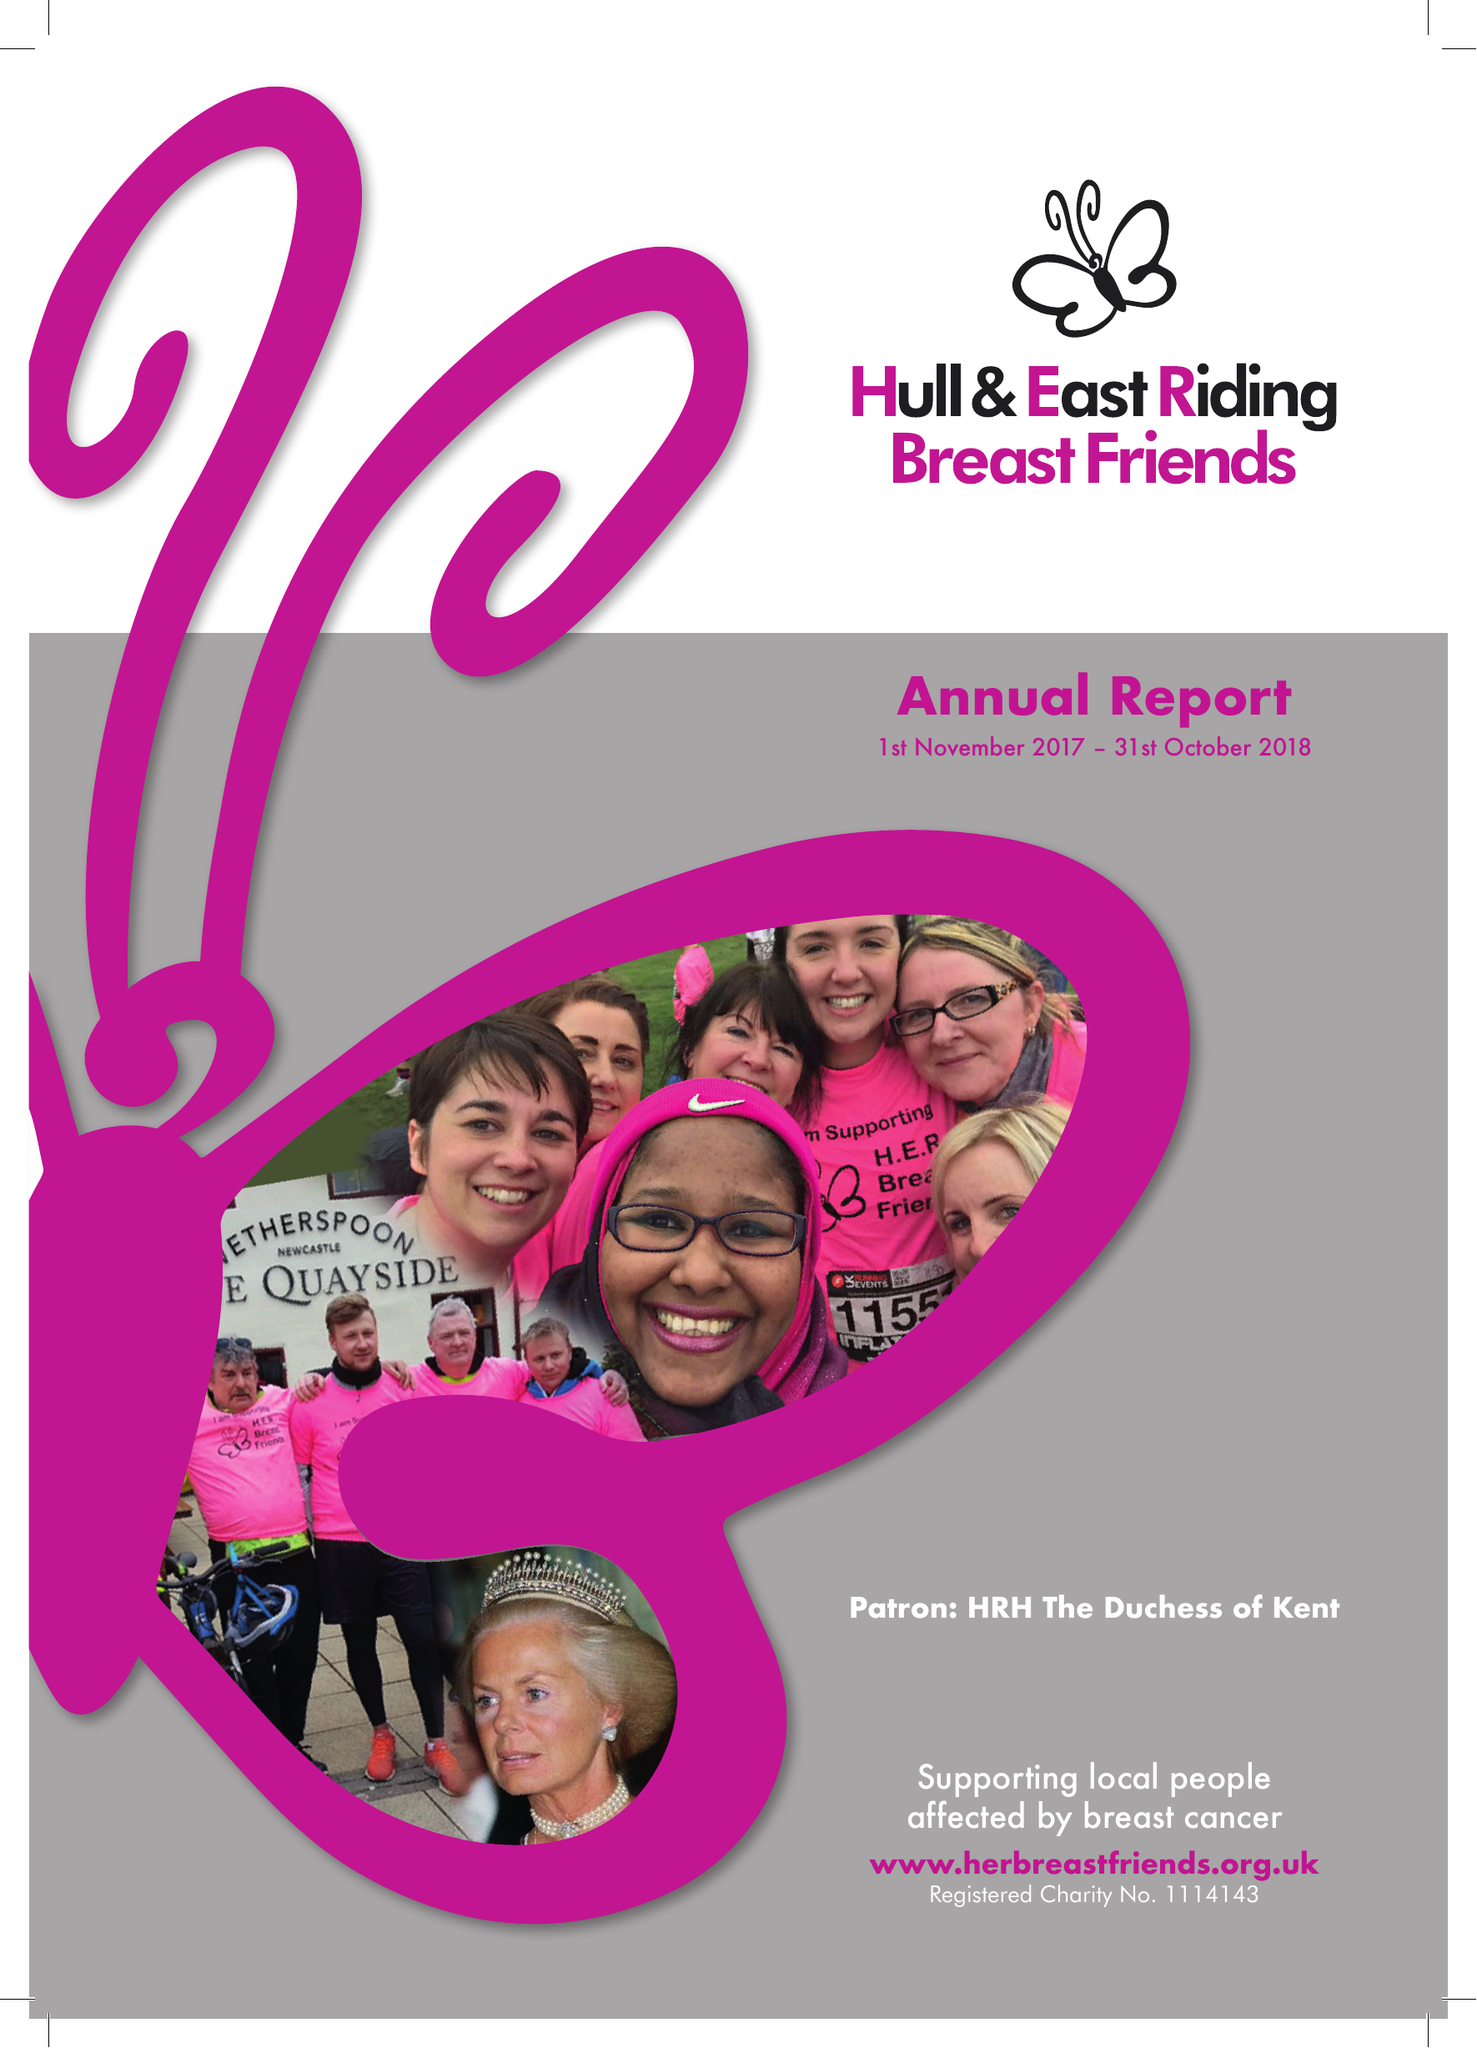What is the value for the charity_name?
Answer the question using a single word or phrase. Hull and East Riding Breast Friends 